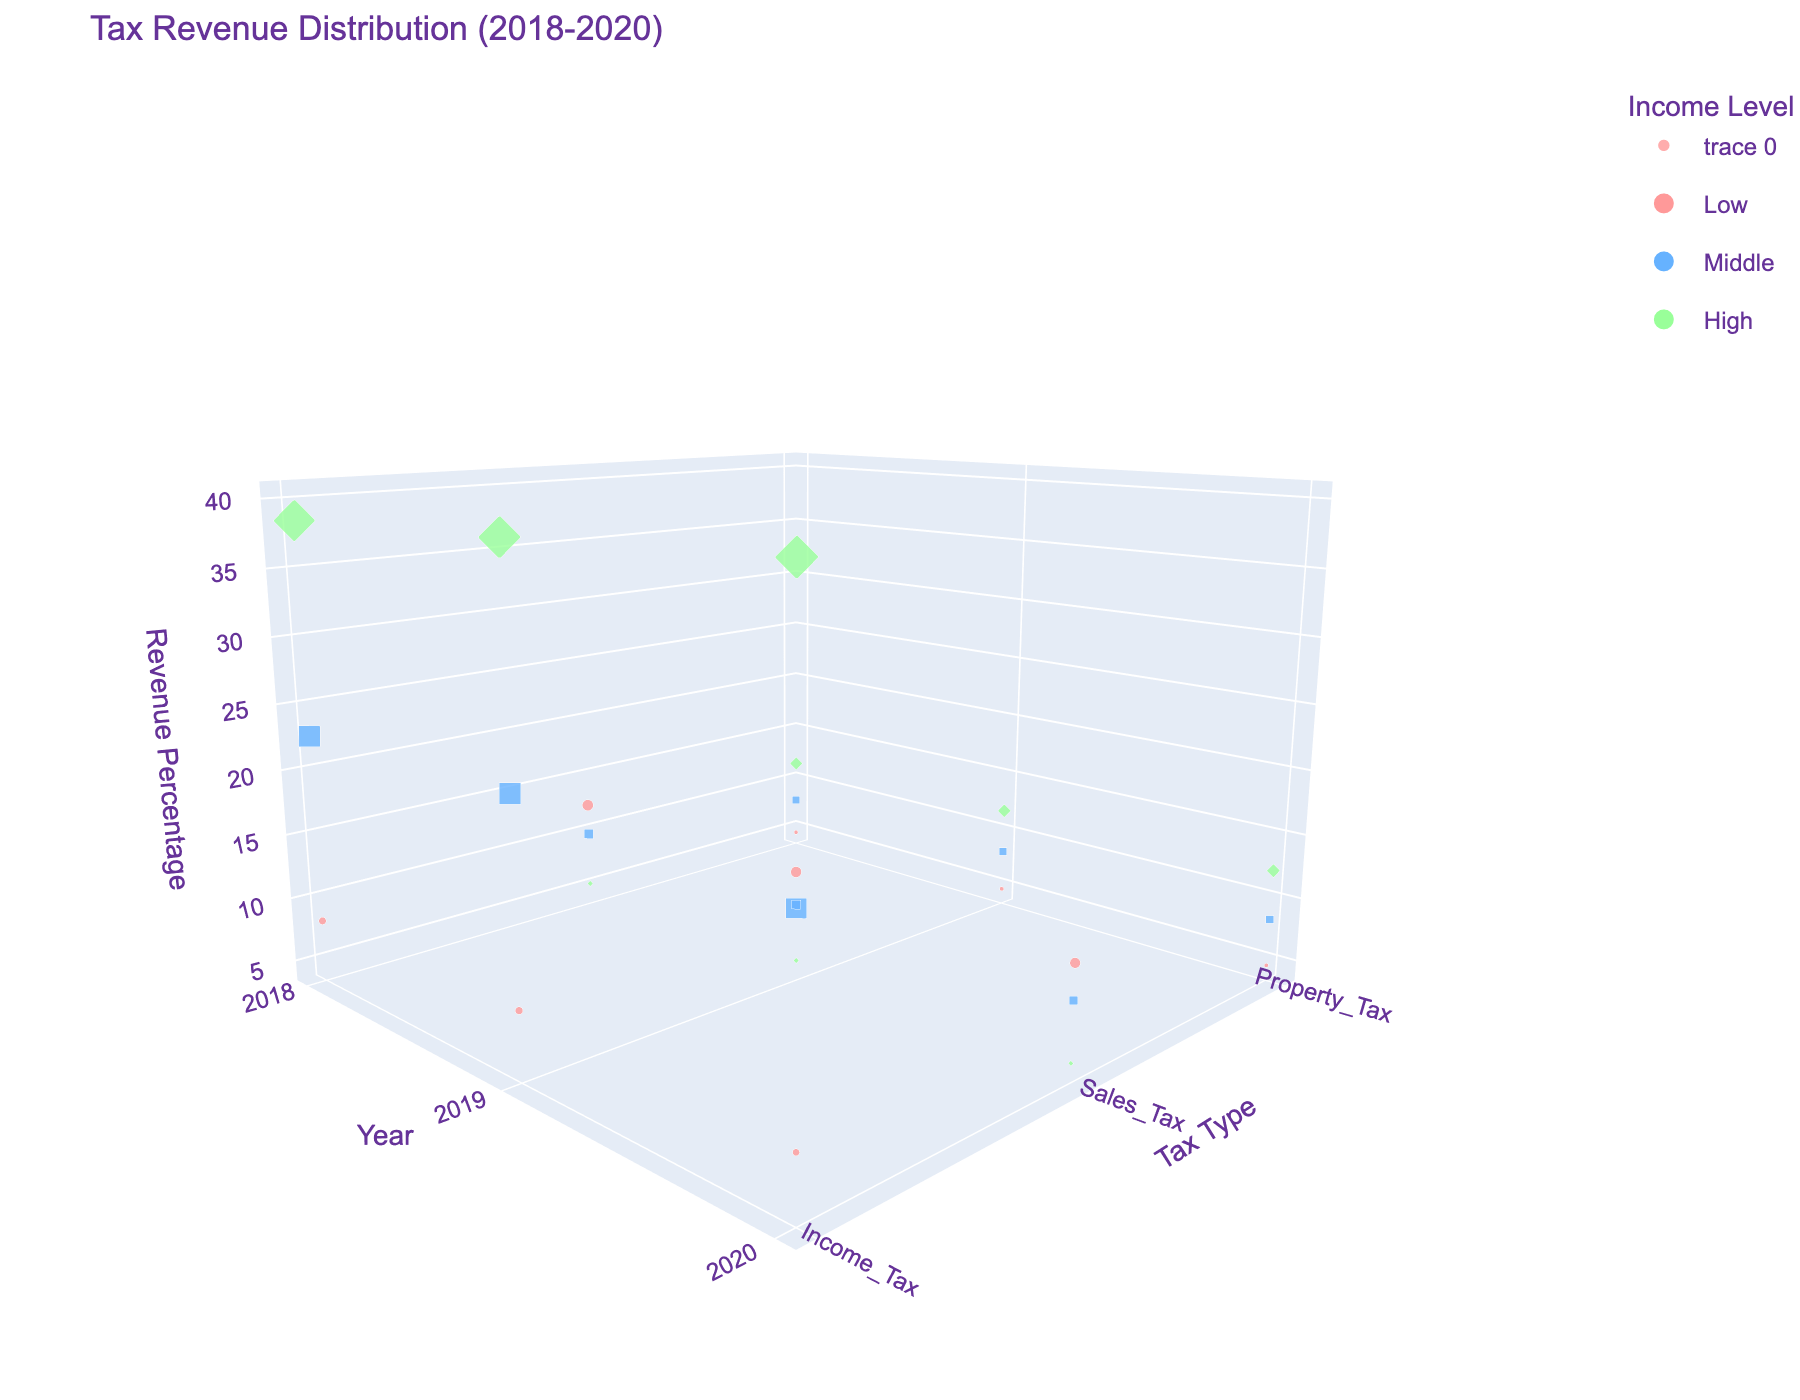What is the title of the figure? The title is displayed at the top of the figure and typically summarizes its content.
Answer: Tax Revenue Distribution (2018-2020) Which income level has the largest percentage of Income Tax revenue in 2020? Look at the 2020 data points in the scatter plot, filter by Income Tax tax type, and identify the one with the highest position on the z-axis.
Answer: High How many tax types are shown in this figure? Observe the y-axis to count the distinct tax types represented.
Answer: 3 Between which years does the figure display data? Look at the x-axis to identify the range of years covered by the data points.
Answer: 2018-2020 What is the revenue percentage of Sales Tax for the middle-income level in 2019? Find the middle-income level data points for the year 2019, then check the Sales Tax type and note the corresponding value on the z-axis.
Answer: 9.5 Which income level shows the highest variation in Income Tax revenue percentage over the years? Compare the variations in Income Tax revenue percentages for all income levels from 2018 to 2020.
Answer: High What is the overall trend of Property Tax revenue for the high-income level from 2018 to 2020? Look at the high-income level data points for Property Tax and observe the change in revenue percentages over the years.
Answer: Increasing Which income level has the lowest average Property Tax revenue percentage from 2018 to 2020? Calculate the average Property Tax revenue percentage for each income level over the three years and identify the lowest one.
Answer: Low Is the Sales Tax revenue percentage consistently decreasing, increasing, or varying for the low-income level from 2018 to 2020? Observe the low-income level data points for Sales Tax over the three years to see if there is a consistent trend.
Answer: Decreasing What is the average Income Tax revenue percentage for the middle-income level from 2018 to 2020? From the middle-income level data points, sum the Income Tax revenue percentages for 2018, 2019, and 2020, then divide by 3.
Answer: 22.5 